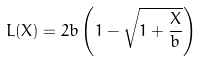<formula> <loc_0><loc_0><loc_500><loc_500>L ( X ) = 2 b \left ( 1 - \sqrt { 1 + \frac { X } { b } } \right )</formula> 